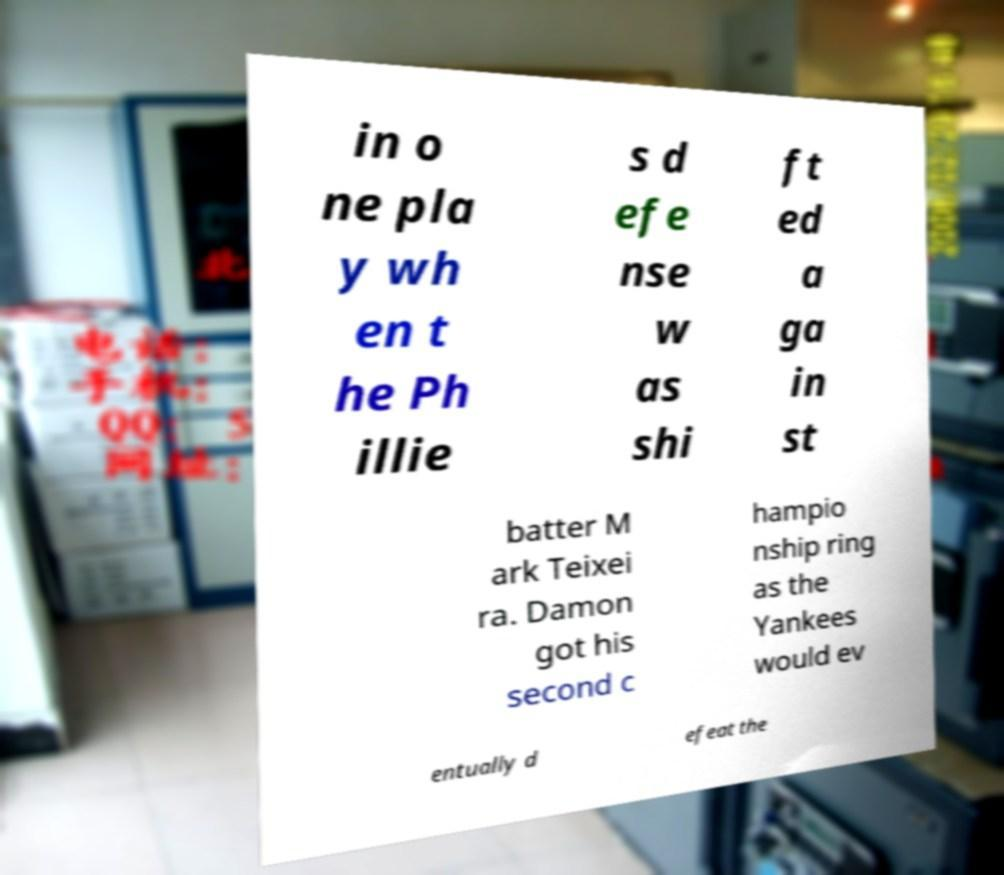Please read and relay the text visible in this image. What does it say? in o ne pla y wh en t he Ph illie s d efe nse w as shi ft ed a ga in st batter M ark Teixei ra. Damon got his second c hampio nship ring as the Yankees would ev entually d efeat the 